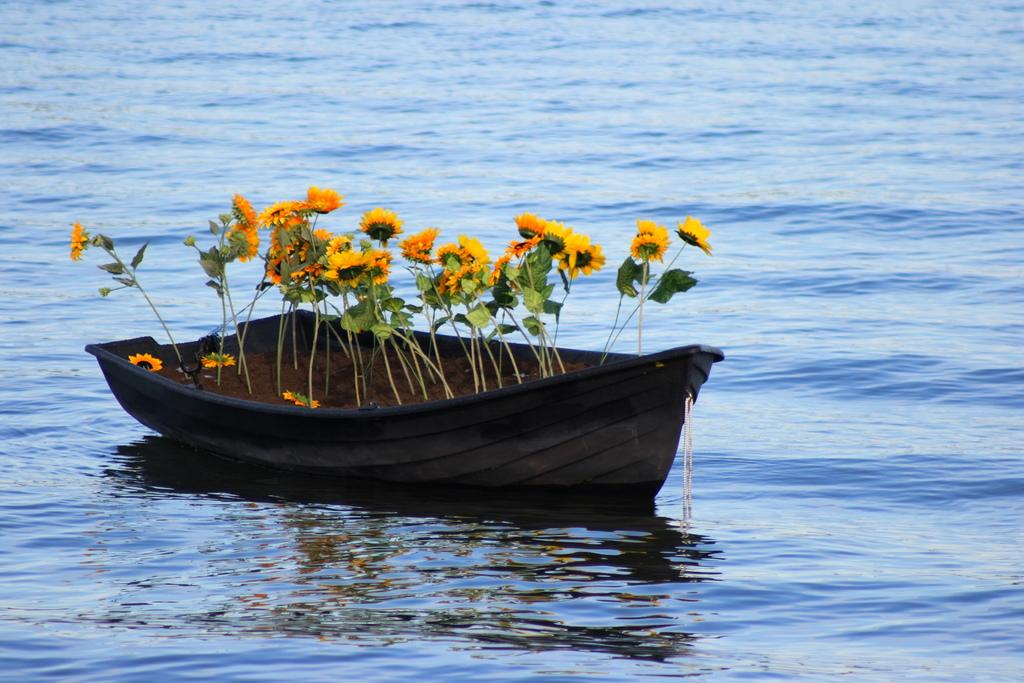What is the main subject of the image? The main subject of the image is a boat. What is inside the boat? The boat contains plants with flowers. Where is the boat located? The boat is sailing on water. What type of knife is being used to cut the water while the boat is sailing? There is no knife present in the image, and the boat is not cutting the water. 